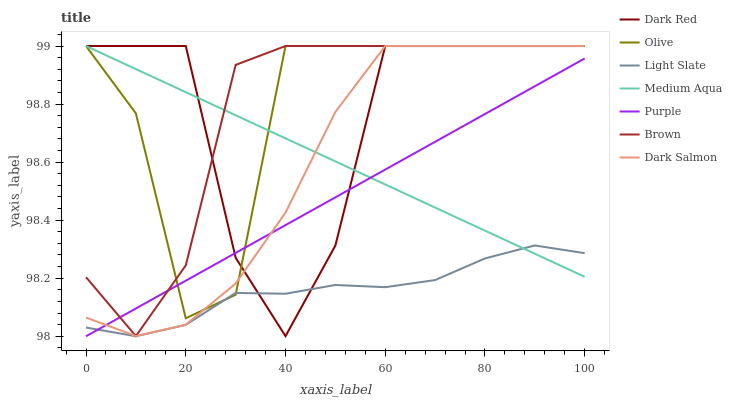Does Light Slate have the minimum area under the curve?
Answer yes or no. Yes. Does Olive have the maximum area under the curve?
Answer yes or no. Yes. Does Purple have the minimum area under the curve?
Answer yes or no. No. Does Purple have the maximum area under the curve?
Answer yes or no. No. Is Medium Aqua the smoothest?
Answer yes or no. Yes. Is Olive the roughest?
Answer yes or no. Yes. Is Purple the smoothest?
Answer yes or no. No. Is Purple the roughest?
Answer yes or no. No. Does Purple have the lowest value?
Answer yes or no. Yes. Does Dark Red have the lowest value?
Answer yes or no. No. Does Olive have the highest value?
Answer yes or no. Yes. Does Purple have the highest value?
Answer yes or no. No. Is Light Slate less than Brown?
Answer yes or no. Yes. Is Brown greater than Light Slate?
Answer yes or no. Yes. Does Medium Aqua intersect Light Slate?
Answer yes or no. Yes. Is Medium Aqua less than Light Slate?
Answer yes or no. No. Is Medium Aqua greater than Light Slate?
Answer yes or no. No. Does Light Slate intersect Brown?
Answer yes or no. No. 